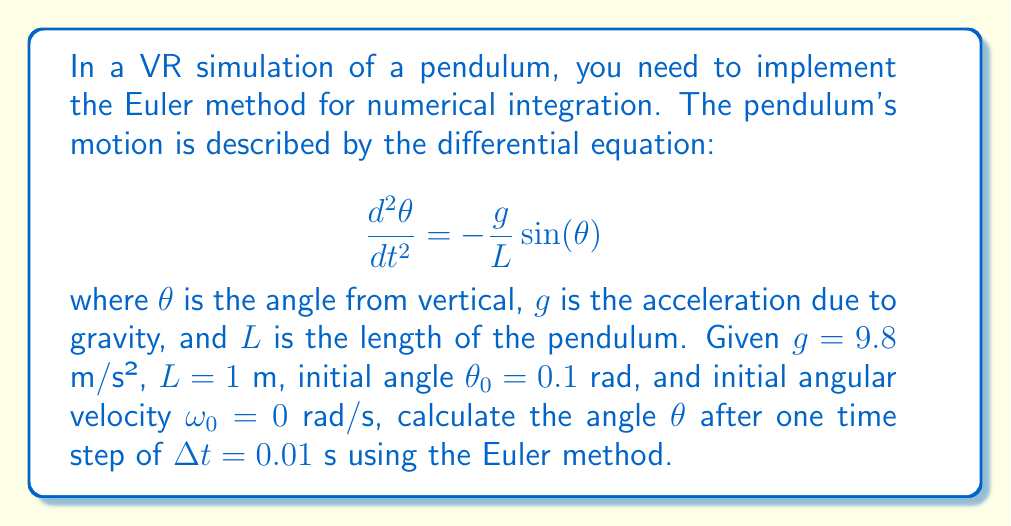Could you help me with this problem? To solve this problem using the Euler method, we need to follow these steps:

1) First, we need to convert the second-order differential equation into two first-order equations:

   $$\frac{d\theta}{dt} = \omega$$
   $$\frac{d\omega}{dt} = -\frac{g}{L}\sin(\theta)$$

2) The Euler method for a system of first-order ODEs is given by:

   $$\theta_{n+1} = \theta_n + \Delta t \cdot \omega_n$$
   $$\omega_{n+1} = \omega_n + \Delta t \cdot (-\frac{g}{L}\sin(\theta_n))$$

3) We are given:
   $g = 9.8$ m/s²
   $L = 1$ m
   $\theta_0 = 0.1$ rad
   $\omega_0 = 0$ rad/s
   $\Delta t = 0.01$ s

4) Let's calculate $\omega_1$:
   $$\omega_1 = \omega_0 + \Delta t \cdot (-\frac{g}{L}\sin(\theta_0))$$
   $$\omega_1 = 0 + 0.01 \cdot (-9.8 \cdot \sin(0.1))$$
   $$\omega_1 = -0.0097951$ rad/s

5) Now we can calculate $\theta_1$:
   $$\theta_1 = \theta_0 + \Delta t \cdot \omega_0$$
   $$\theta_1 = 0.1 + 0.01 \cdot 0 = 0.1$ rad

Therefore, after one time step, the new angle $\theta_1$ is 0.1 rad.
Answer: 0.1 rad 